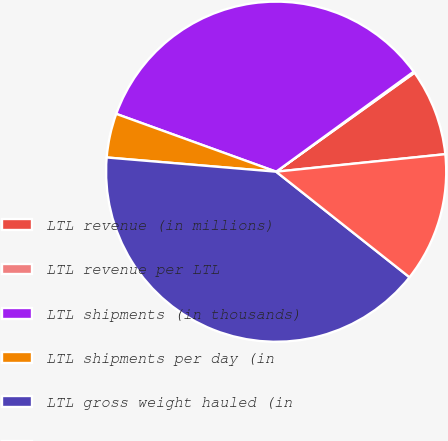Convert chart to OTSL. <chart><loc_0><loc_0><loc_500><loc_500><pie_chart><fcel>LTL revenue (in millions)<fcel>LTL revenue per LTL<fcel>LTL shipments (in thousands)<fcel>LTL shipments per day (in<fcel>LTL gross weight hauled (in<fcel>LTL weight per shipment<nl><fcel>8.24%<fcel>0.13%<fcel>34.47%<fcel>4.19%<fcel>40.68%<fcel>12.3%<nl></chart> 